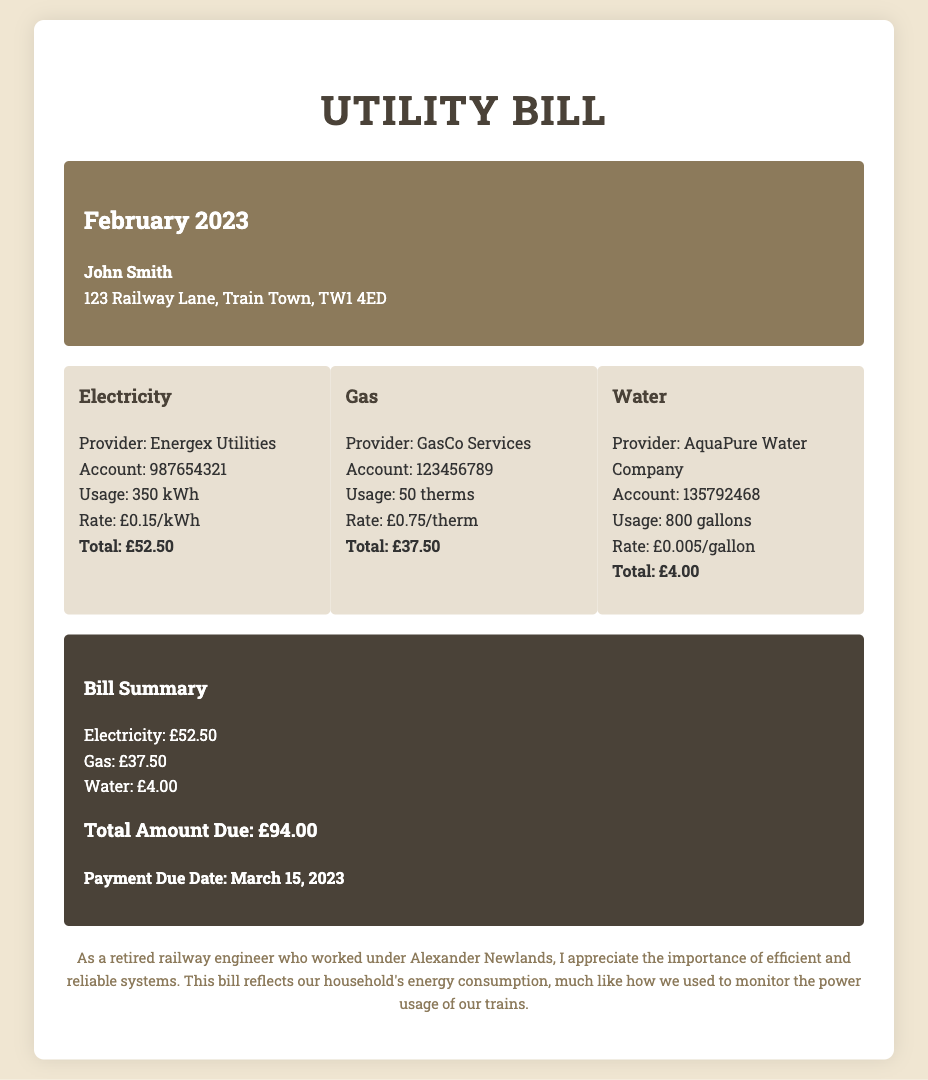what is the total amount due? The total amount due is presented in the summary section of the document as the sum of all charges.
Answer: £94.00 who is the electricity provider? The document specifies the electricity provider in the charge breakdown for electricity.
Answer: Energex Utilities how much was spent on gas? The total gas charge is listed under the gas breakdown in the charges section.
Answer: £37.50 what is the usage for water in gallons? The document states the water usage in the charge breakdown for water.
Answer: 800 gallons when is the payment due date? The due date for payment is clearly mentioned at the bottom of the summary section.
Answer: March 15, 2023 how many kilowatt-hours were consumed? The document provides this information in the electricity charge breakdown.
Answer: 350 kWh what is the rate per therm for gas? The rate for gas is found in the charge details of the gas section.
Answer: £0.75/therm who is the water provider? The provider of water is mentioned in the water charge breakdown.
Answer: AquaPure Water Company what is the total for electricity? The total charge for electricity is provided in the electricity section of the document.
Answer: £52.50 